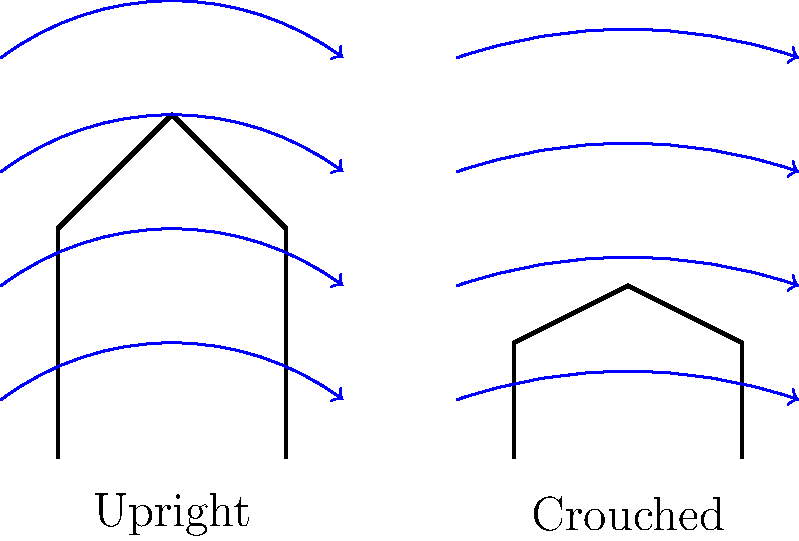Based on the airflow patterns shown in the diagram, which jockey posture is likely to result in lower drag and potentially faster speeds during a race? To determine which jockey posture results in lower drag and potentially faster speeds, we need to analyze the airflow patterns around each position:

1. Upright position:
   - The jockey's body is more vertical, creating a larger frontal area.
   - Airflow lines are more disrupted and curve significantly around the jockey.
   - More air is displaced, leading to increased turbulence behind the jockey.

2. Crouched position:
   - The jockey's body is more horizontal, reducing the frontal area.
   - Airflow lines are smoother and follow the contour of the jockey's back more closely.
   - Less air is displaced, resulting in reduced turbulence behind the jockey.

3. Aerodynamic principles:
   - Drag force is proportional to the frontal area exposed to airflow.
   - Smoother airflow typically indicates less drag.
   - Reduced turbulence behind an object generally results in lower drag.

4. Conclusion:
   The crouched position shows smoother airflow patterns, less air displacement, and reduced frontal area. These factors all contribute to lower drag.

Therefore, the crouched posture is likely to result in lower drag and potentially faster speeds during a race.
Answer: Crouched posture 